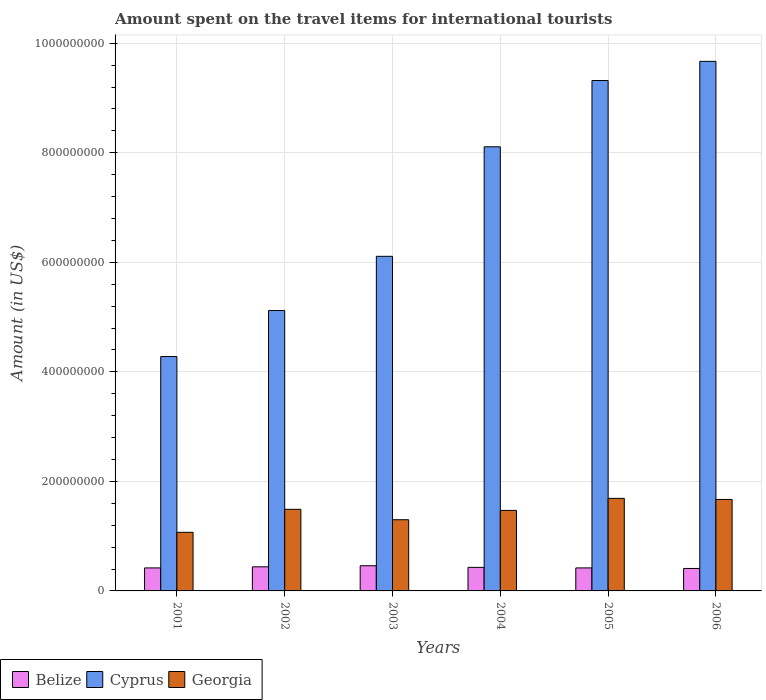How many groups of bars are there?
Provide a short and direct response. 6. Are the number of bars per tick equal to the number of legend labels?
Provide a short and direct response. Yes. How many bars are there on the 5th tick from the right?
Provide a short and direct response. 3. In how many cases, is the number of bars for a given year not equal to the number of legend labels?
Keep it short and to the point. 0. What is the amount spent on the travel items for international tourists in Cyprus in 2004?
Your response must be concise. 8.11e+08. Across all years, what is the maximum amount spent on the travel items for international tourists in Georgia?
Ensure brevity in your answer.  1.69e+08. Across all years, what is the minimum amount spent on the travel items for international tourists in Cyprus?
Provide a short and direct response. 4.28e+08. In which year was the amount spent on the travel items for international tourists in Georgia minimum?
Keep it short and to the point. 2001. What is the total amount spent on the travel items for international tourists in Georgia in the graph?
Ensure brevity in your answer.  8.69e+08. What is the difference between the amount spent on the travel items for international tourists in Georgia in 2001 and the amount spent on the travel items for international tourists in Cyprus in 2002?
Make the answer very short. -4.05e+08. What is the average amount spent on the travel items for international tourists in Belize per year?
Offer a very short reply. 4.30e+07. In the year 2003, what is the difference between the amount spent on the travel items for international tourists in Georgia and amount spent on the travel items for international tourists in Cyprus?
Your answer should be very brief. -4.81e+08. What is the ratio of the amount spent on the travel items for international tourists in Georgia in 2002 to that in 2003?
Give a very brief answer. 1.15. What is the difference between the highest and the second highest amount spent on the travel items for international tourists in Georgia?
Provide a short and direct response. 2.00e+06. What is the difference between the highest and the lowest amount spent on the travel items for international tourists in Belize?
Offer a terse response. 5.00e+06. In how many years, is the amount spent on the travel items for international tourists in Belize greater than the average amount spent on the travel items for international tourists in Belize taken over all years?
Your response must be concise. 2. Is the sum of the amount spent on the travel items for international tourists in Belize in 2001 and 2002 greater than the maximum amount spent on the travel items for international tourists in Cyprus across all years?
Ensure brevity in your answer.  No. What does the 3rd bar from the left in 2006 represents?
Provide a short and direct response. Georgia. What does the 1st bar from the right in 2006 represents?
Your response must be concise. Georgia. Is it the case that in every year, the sum of the amount spent on the travel items for international tourists in Georgia and amount spent on the travel items for international tourists in Cyprus is greater than the amount spent on the travel items for international tourists in Belize?
Provide a succinct answer. Yes. What is the difference between two consecutive major ticks on the Y-axis?
Ensure brevity in your answer.  2.00e+08. Does the graph contain any zero values?
Your answer should be very brief. No. Does the graph contain grids?
Ensure brevity in your answer.  Yes. How are the legend labels stacked?
Make the answer very short. Horizontal. What is the title of the graph?
Your answer should be very brief. Amount spent on the travel items for international tourists. What is the label or title of the Y-axis?
Your answer should be compact. Amount (in US$). What is the Amount (in US$) of Belize in 2001?
Give a very brief answer. 4.20e+07. What is the Amount (in US$) in Cyprus in 2001?
Your response must be concise. 4.28e+08. What is the Amount (in US$) of Georgia in 2001?
Your answer should be compact. 1.07e+08. What is the Amount (in US$) of Belize in 2002?
Ensure brevity in your answer.  4.40e+07. What is the Amount (in US$) in Cyprus in 2002?
Your answer should be compact. 5.12e+08. What is the Amount (in US$) of Georgia in 2002?
Your answer should be compact. 1.49e+08. What is the Amount (in US$) of Belize in 2003?
Provide a short and direct response. 4.60e+07. What is the Amount (in US$) in Cyprus in 2003?
Provide a succinct answer. 6.11e+08. What is the Amount (in US$) of Georgia in 2003?
Provide a short and direct response. 1.30e+08. What is the Amount (in US$) of Belize in 2004?
Provide a short and direct response. 4.30e+07. What is the Amount (in US$) in Cyprus in 2004?
Your response must be concise. 8.11e+08. What is the Amount (in US$) of Georgia in 2004?
Make the answer very short. 1.47e+08. What is the Amount (in US$) of Belize in 2005?
Keep it short and to the point. 4.20e+07. What is the Amount (in US$) in Cyprus in 2005?
Make the answer very short. 9.32e+08. What is the Amount (in US$) in Georgia in 2005?
Your response must be concise. 1.69e+08. What is the Amount (in US$) of Belize in 2006?
Provide a short and direct response. 4.10e+07. What is the Amount (in US$) of Cyprus in 2006?
Your answer should be compact. 9.67e+08. What is the Amount (in US$) in Georgia in 2006?
Your answer should be compact. 1.67e+08. Across all years, what is the maximum Amount (in US$) in Belize?
Provide a succinct answer. 4.60e+07. Across all years, what is the maximum Amount (in US$) in Cyprus?
Make the answer very short. 9.67e+08. Across all years, what is the maximum Amount (in US$) of Georgia?
Give a very brief answer. 1.69e+08. Across all years, what is the minimum Amount (in US$) of Belize?
Your answer should be very brief. 4.10e+07. Across all years, what is the minimum Amount (in US$) in Cyprus?
Make the answer very short. 4.28e+08. Across all years, what is the minimum Amount (in US$) in Georgia?
Offer a very short reply. 1.07e+08. What is the total Amount (in US$) of Belize in the graph?
Ensure brevity in your answer.  2.58e+08. What is the total Amount (in US$) in Cyprus in the graph?
Ensure brevity in your answer.  4.26e+09. What is the total Amount (in US$) of Georgia in the graph?
Ensure brevity in your answer.  8.69e+08. What is the difference between the Amount (in US$) in Belize in 2001 and that in 2002?
Offer a terse response. -2.00e+06. What is the difference between the Amount (in US$) of Cyprus in 2001 and that in 2002?
Provide a short and direct response. -8.40e+07. What is the difference between the Amount (in US$) in Georgia in 2001 and that in 2002?
Offer a terse response. -4.20e+07. What is the difference between the Amount (in US$) of Cyprus in 2001 and that in 2003?
Provide a short and direct response. -1.83e+08. What is the difference between the Amount (in US$) of Georgia in 2001 and that in 2003?
Give a very brief answer. -2.30e+07. What is the difference between the Amount (in US$) of Belize in 2001 and that in 2004?
Offer a very short reply. -1.00e+06. What is the difference between the Amount (in US$) in Cyprus in 2001 and that in 2004?
Offer a very short reply. -3.83e+08. What is the difference between the Amount (in US$) in Georgia in 2001 and that in 2004?
Provide a short and direct response. -4.00e+07. What is the difference between the Amount (in US$) in Belize in 2001 and that in 2005?
Offer a terse response. 0. What is the difference between the Amount (in US$) in Cyprus in 2001 and that in 2005?
Make the answer very short. -5.04e+08. What is the difference between the Amount (in US$) of Georgia in 2001 and that in 2005?
Offer a terse response. -6.20e+07. What is the difference between the Amount (in US$) of Belize in 2001 and that in 2006?
Provide a short and direct response. 1.00e+06. What is the difference between the Amount (in US$) of Cyprus in 2001 and that in 2006?
Offer a terse response. -5.39e+08. What is the difference between the Amount (in US$) in Georgia in 2001 and that in 2006?
Offer a very short reply. -6.00e+07. What is the difference between the Amount (in US$) in Belize in 2002 and that in 2003?
Offer a very short reply. -2.00e+06. What is the difference between the Amount (in US$) of Cyprus in 2002 and that in 2003?
Give a very brief answer. -9.90e+07. What is the difference between the Amount (in US$) of Georgia in 2002 and that in 2003?
Provide a succinct answer. 1.90e+07. What is the difference between the Amount (in US$) in Belize in 2002 and that in 2004?
Your response must be concise. 1.00e+06. What is the difference between the Amount (in US$) of Cyprus in 2002 and that in 2004?
Offer a very short reply. -2.99e+08. What is the difference between the Amount (in US$) in Cyprus in 2002 and that in 2005?
Provide a short and direct response. -4.20e+08. What is the difference between the Amount (in US$) in Georgia in 2002 and that in 2005?
Make the answer very short. -2.00e+07. What is the difference between the Amount (in US$) in Belize in 2002 and that in 2006?
Offer a very short reply. 3.00e+06. What is the difference between the Amount (in US$) in Cyprus in 2002 and that in 2006?
Keep it short and to the point. -4.55e+08. What is the difference between the Amount (in US$) in Georgia in 2002 and that in 2006?
Your response must be concise. -1.80e+07. What is the difference between the Amount (in US$) of Belize in 2003 and that in 2004?
Your response must be concise. 3.00e+06. What is the difference between the Amount (in US$) in Cyprus in 2003 and that in 2004?
Your answer should be compact. -2.00e+08. What is the difference between the Amount (in US$) of Georgia in 2003 and that in 2004?
Your answer should be very brief. -1.70e+07. What is the difference between the Amount (in US$) in Belize in 2003 and that in 2005?
Your answer should be compact. 4.00e+06. What is the difference between the Amount (in US$) of Cyprus in 2003 and that in 2005?
Make the answer very short. -3.21e+08. What is the difference between the Amount (in US$) in Georgia in 2003 and that in 2005?
Offer a terse response. -3.90e+07. What is the difference between the Amount (in US$) in Belize in 2003 and that in 2006?
Keep it short and to the point. 5.00e+06. What is the difference between the Amount (in US$) in Cyprus in 2003 and that in 2006?
Make the answer very short. -3.56e+08. What is the difference between the Amount (in US$) of Georgia in 2003 and that in 2006?
Your response must be concise. -3.70e+07. What is the difference between the Amount (in US$) of Cyprus in 2004 and that in 2005?
Make the answer very short. -1.21e+08. What is the difference between the Amount (in US$) in Georgia in 2004 and that in 2005?
Your answer should be compact. -2.20e+07. What is the difference between the Amount (in US$) of Belize in 2004 and that in 2006?
Give a very brief answer. 2.00e+06. What is the difference between the Amount (in US$) in Cyprus in 2004 and that in 2006?
Ensure brevity in your answer.  -1.56e+08. What is the difference between the Amount (in US$) of Georgia in 2004 and that in 2006?
Your answer should be very brief. -2.00e+07. What is the difference between the Amount (in US$) in Cyprus in 2005 and that in 2006?
Keep it short and to the point. -3.50e+07. What is the difference between the Amount (in US$) of Belize in 2001 and the Amount (in US$) of Cyprus in 2002?
Your answer should be very brief. -4.70e+08. What is the difference between the Amount (in US$) of Belize in 2001 and the Amount (in US$) of Georgia in 2002?
Offer a terse response. -1.07e+08. What is the difference between the Amount (in US$) in Cyprus in 2001 and the Amount (in US$) in Georgia in 2002?
Offer a very short reply. 2.79e+08. What is the difference between the Amount (in US$) of Belize in 2001 and the Amount (in US$) of Cyprus in 2003?
Your answer should be very brief. -5.69e+08. What is the difference between the Amount (in US$) of Belize in 2001 and the Amount (in US$) of Georgia in 2003?
Your answer should be very brief. -8.80e+07. What is the difference between the Amount (in US$) of Cyprus in 2001 and the Amount (in US$) of Georgia in 2003?
Offer a terse response. 2.98e+08. What is the difference between the Amount (in US$) in Belize in 2001 and the Amount (in US$) in Cyprus in 2004?
Provide a short and direct response. -7.69e+08. What is the difference between the Amount (in US$) in Belize in 2001 and the Amount (in US$) in Georgia in 2004?
Make the answer very short. -1.05e+08. What is the difference between the Amount (in US$) in Cyprus in 2001 and the Amount (in US$) in Georgia in 2004?
Keep it short and to the point. 2.81e+08. What is the difference between the Amount (in US$) of Belize in 2001 and the Amount (in US$) of Cyprus in 2005?
Your response must be concise. -8.90e+08. What is the difference between the Amount (in US$) in Belize in 2001 and the Amount (in US$) in Georgia in 2005?
Give a very brief answer. -1.27e+08. What is the difference between the Amount (in US$) of Cyprus in 2001 and the Amount (in US$) of Georgia in 2005?
Keep it short and to the point. 2.59e+08. What is the difference between the Amount (in US$) in Belize in 2001 and the Amount (in US$) in Cyprus in 2006?
Your answer should be compact. -9.25e+08. What is the difference between the Amount (in US$) in Belize in 2001 and the Amount (in US$) in Georgia in 2006?
Your answer should be compact. -1.25e+08. What is the difference between the Amount (in US$) of Cyprus in 2001 and the Amount (in US$) of Georgia in 2006?
Offer a very short reply. 2.61e+08. What is the difference between the Amount (in US$) in Belize in 2002 and the Amount (in US$) in Cyprus in 2003?
Ensure brevity in your answer.  -5.67e+08. What is the difference between the Amount (in US$) of Belize in 2002 and the Amount (in US$) of Georgia in 2003?
Your answer should be very brief. -8.60e+07. What is the difference between the Amount (in US$) of Cyprus in 2002 and the Amount (in US$) of Georgia in 2003?
Your answer should be compact. 3.82e+08. What is the difference between the Amount (in US$) of Belize in 2002 and the Amount (in US$) of Cyprus in 2004?
Offer a terse response. -7.67e+08. What is the difference between the Amount (in US$) of Belize in 2002 and the Amount (in US$) of Georgia in 2004?
Offer a very short reply. -1.03e+08. What is the difference between the Amount (in US$) of Cyprus in 2002 and the Amount (in US$) of Georgia in 2004?
Your answer should be very brief. 3.65e+08. What is the difference between the Amount (in US$) of Belize in 2002 and the Amount (in US$) of Cyprus in 2005?
Provide a short and direct response. -8.88e+08. What is the difference between the Amount (in US$) of Belize in 2002 and the Amount (in US$) of Georgia in 2005?
Provide a succinct answer. -1.25e+08. What is the difference between the Amount (in US$) of Cyprus in 2002 and the Amount (in US$) of Georgia in 2005?
Your answer should be very brief. 3.43e+08. What is the difference between the Amount (in US$) in Belize in 2002 and the Amount (in US$) in Cyprus in 2006?
Offer a terse response. -9.23e+08. What is the difference between the Amount (in US$) of Belize in 2002 and the Amount (in US$) of Georgia in 2006?
Ensure brevity in your answer.  -1.23e+08. What is the difference between the Amount (in US$) in Cyprus in 2002 and the Amount (in US$) in Georgia in 2006?
Ensure brevity in your answer.  3.45e+08. What is the difference between the Amount (in US$) of Belize in 2003 and the Amount (in US$) of Cyprus in 2004?
Your answer should be compact. -7.65e+08. What is the difference between the Amount (in US$) in Belize in 2003 and the Amount (in US$) in Georgia in 2004?
Your response must be concise. -1.01e+08. What is the difference between the Amount (in US$) in Cyprus in 2003 and the Amount (in US$) in Georgia in 2004?
Give a very brief answer. 4.64e+08. What is the difference between the Amount (in US$) in Belize in 2003 and the Amount (in US$) in Cyprus in 2005?
Your response must be concise. -8.86e+08. What is the difference between the Amount (in US$) of Belize in 2003 and the Amount (in US$) of Georgia in 2005?
Provide a succinct answer. -1.23e+08. What is the difference between the Amount (in US$) in Cyprus in 2003 and the Amount (in US$) in Georgia in 2005?
Your answer should be compact. 4.42e+08. What is the difference between the Amount (in US$) in Belize in 2003 and the Amount (in US$) in Cyprus in 2006?
Give a very brief answer. -9.21e+08. What is the difference between the Amount (in US$) of Belize in 2003 and the Amount (in US$) of Georgia in 2006?
Offer a very short reply. -1.21e+08. What is the difference between the Amount (in US$) in Cyprus in 2003 and the Amount (in US$) in Georgia in 2006?
Keep it short and to the point. 4.44e+08. What is the difference between the Amount (in US$) in Belize in 2004 and the Amount (in US$) in Cyprus in 2005?
Make the answer very short. -8.89e+08. What is the difference between the Amount (in US$) in Belize in 2004 and the Amount (in US$) in Georgia in 2005?
Offer a terse response. -1.26e+08. What is the difference between the Amount (in US$) of Cyprus in 2004 and the Amount (in US$) of Georgia in 2005?
Your answer should be very brief. 6.42e+08. What is the difference between the Amount (in US$) in Belize in 2004 and the Amount (in US$) in Cyprus in 2006?
Provide a succinct answer. -9.24e+08. What is the difference between the Amount (in US$) of Belize in 2004 and the Amount (in US$) of Georgia in 2006?
Your answer should be compact. -1.24e+08. What is the difference between the Amount (in US$) in Cyprus in 2004 and the Amount (in US$) in Georgia in 2006?
Provide a short and direct response. 6.44e+08. What is the difference between the Amount (in US$) in Belize in 2005 and the Amount (in US$) in Cyprus in 2006?
Give a very brief answer. -9.25e+08. What is the difference between the Amount (in US$) in Belize in 2005 and the Amount (in US$) in Georgia in 2006?
Offer a very short reply. -1.25e+08. What is the difference between the Amount (in US$) in Cyprus in 2005 and the Amount (in US$) in Georgia in 2006?
Your answer should be compact. 7.65e+08. What is the average Amount (in US$) of Belize per year?
Keep it short and to the point. 4.30e+07. What is the average Amount (in US$) of Cyprus per year?
Keep it short and to the point. 7.10e+08. What is the average Amount (in US$) of Georgia per year?
Your response must be concise. 1.45e+08. In the year 2001, what is the difference between the Amount (in US$) of Belize and Amount (in US$) of Cyprus?
Offer a very short reply. -3.86e+08. In the year 2001, what is the difference between the Amount (in US$) in Belize and Amount (in US$) in Georgia?
Provide a succinct answer. -6.50e+07. In the year 2001, what is the difference between the Amount (in US$) in Cyprus and Amount (in US$) in Georgia?
Keep it short and to the point. 3.21e+08. In the year 2002, what is the difference between the Amount (in US$) in Belize and Amount (in US$) in Cyprus?
Provide a succinct answer. -4.68e+08. In the year 2002, what is the difference between the Amount (in US$) of Belize and Amount (in US$) of Georgia?
Your answer should be very brief. -1.05e+08. In the year 2002, what is the difference between the Amount (in US$) of Cyprus and Amount (in US$) of Georgia?
Keep it short and to the point. 3.63e+08. In the year 2003, what is the difference between the Amount (in US$) of Belize and Amount (in US$) of Cyprus?
Give a very brief answer. -5.65e+08. In the year 2003, what is the difference between the Amount (in US$) in Belize and Amount (in US$) in Georgia?
Your answer should be very brief. -8.40e+07. In the year 2003, what is the difference between the Amount (in US$) of Cyprus and Amount (in US$) of Georgia?
Your response must be concise. 4.81e+08. In the year 2004, what is the difference between the Amount (in US$) in Belize and Amount (in US$) in Cyprus?
Provide a succinct answer. -7.68e+08. In the year 2004, what is the difference between the Amount (in US$) of Belize and Amount (in US$) of Georgia?
Your response must be concise. -1.04e+08. In the year 2004, what is the difference between the Amount (in US$) in Cyprus and Amount (in US$) in Georgia?
Give a very brief answer. 6.64e+08. In the year 2005, what is the difference between the Amount (in US$) in Belize and Amount (in US$) in Cyprus?
Give a very brief answer. -8.90e+08. In the year 2005, what is the difference between the Amount (in US$) of Belize and Amount (in US$) of Georgia?
Make the answer very short. -1.27e+08. In the year 2005, what is the difference between the Amount (in US$) of Cyprus and Amount (in US$) of Georgia?
Provide a short and direct response. 7.63e+08. In the year 2006, what is the difference between the Amount (in US$) of Belize and Amount (in US$) of Cyprus?
Give a very brief answer. -9.26e+08. In the year 2006, what is the difference between the Amount (in US$) in Belize and Amount (in US$) in Georgia?
Your answer should be very brief. -1.26e+08. In the year 2006, what is the difference between the Amount (in US$) in Cyprus and Amount (in US$) in Georgia?
Your answer should be compact. 8.00e+08. What is the ratio of the Amount (in US$) in Belize in 2001 to that in 2002?
Offer a very short reply. 0.95. What is the ratio of the Amount (in US$) of Cyprus in 2001 to that in 2002?
Provide a succinct answer. 0.84. What is the ratio of the Amount (in US$) of Georgia in 2001 to that in 2002?
Provide a succinct answer. 0.72. What is the ratio of the Amount (in US$) of Cyprus in 2001 to that in 2003?
Keep it short and to the point. 0.7. What is the ratio of the Amount (in US$) of Georgia in 2001 to that in 2003?
Offer a terse response. 0.82. What is the ratio of the Amount (in US$) of Belize in 2001 to that in 2004?
Your response must be concise. 0.98. What is the ratio of the Amount (in US$) in Cyprus in 2001 to that in 2004?
Make the answer very short. 0.53. What is the ratio of the Amount (in US$) in Georgia in 2001 to that in 2004?
Offer a terse response. 0.73. What is the ratio of the Amount (in US$) of Cyprus in 2001 to that in 2005?
Ensure brevity in your answer.  0.46. What is the ratio of the Amount (in US$) in Georgia in 2001 to that in 2005?
Provide a succinct answer. 0.63. What is the ratio of the Amount (in US$) in Belize in 2001 to that in 2006?
Ensure brevity in your answer.  1.02. What is the ratio of the Amount (in US$) in Cyprus in 2001 to that in 2006?
Offer a terse response. 0.44. What is the ratio of the Amount (in US$) in Georgia in 2001 to that in 2006?
Give a very brief answer. 0.64. What is the ratio of the Amount (in US$) in Belize in 2002 to that in 2003?
Provide a short and direct response. 0.96. What is the ratio of the Amount (in US$) in Cyprus in 2002 to that in 2003?
Provide a short and direct response. 0.84. What is the ratio of the Amount (in US$) of Georgia in 2002 to that in 2003?
Provide a short and direct response. 1.15. What is the ratio of the Amount (in US$) in Belize in 2002 to that in 2004?
Your answer should be very brief. 1.02. What is the ratio of the Amount (in US$) in Cyprus in 2002 to that in 2004?
Provide a short and direct response. 0.63. What is the ratio of the Amount (in US$) of Georgia in 2002 to that in 2004?
Ensure brevity in your answer.  1.01. What is the ratio of the Amount (in US$) in Belize in 2002 to that in 2005?
Provide a succinct answer. 1.05. What is the ratio of the Amount (in US$) in Cyprus in 2002 to that in 2005?
Offer a terse response. 0.55. What is the ratio of the Amount (in US$) of Georgia in 2002 to that in 2005?
Offer a very short reply. 0.88. What is the ratio of the Amount (in US$) in Belize in 2002 to that in 2006?
Keep it short and to the point. 1.07. What is the ratio of the Amount (in US$) of Cyprus in 2002 to that in 2006?
Make the answer very short. 0.53. What is the ratio of the Amount (in US$) of Georgia in 2002 to that in 2006?
Your response must be concise. 0.89. What is the ratio of the Amount (in US$) of Belize in 2003 to that in 2004?
Give a very brief answer. 1.07. What is the ratio of the Amount (in US$) in Cyprus in 2003 to that in 2004?
Offer a very short reply. 0.75. What is the ratio of the Amount (in US$) of Georgia in 2003 to that in 2004?
Ensure brevity in your answer.  0.88. What is the ratio of the Amount (in US$) in Belize in 2003 to that in 2005?
Offer a very short reply. 1.1. What is the ratio of the Amount (in US$) in Cyprus in 2003 to that in 2005?
Keep it short and to the point. 0.66. What is the ratio of the Amount (in US$) of Georgia in 2003 to that in 2005?
Offer a terse response. 0.77. What is the ratio of the Amount (in US$) in Belize in 2003 to that in 2006?
Your response must be concise. 1.12. What is the ratio of the Amount (in US$) in Cyprus in 2003 to that in 2006?
Your response must be concise. 0.63. What is the ratio of the Amount (in US$) in Georgia in 2003 to that in 2006?
Make the answer very short. 0.78. What is the ratio of the Amount (in US$) in Belize in 2004 to that in 2005?
Give a very brief answer. 1.02. What is the ratio of the Amount (in US$) of Cyprus in 2004 to that in 2005?
Provide a short and direct response. 0.87. What is the ratio of the Amount (in US$) of Georgia in 2004 to that in 2005?
Provide a succinct answer. 0.87. What is the ratio of the Amount (in US$) of Belize in 2004 to that in 2006?
Ensure brevity in your answer.  1.05. What is the ratio of the Amount (in US$) of Cyprus in 2004 to that in 2006?
Make the answer very short. 0.84. What is the ratio of the Amount (in US$) in Georgia in 2004 to that in 2006?
Your response must be concise. 0.88. What is the ratio of the Amount (in US$) in Belize in 2005 to that in 2006?
Provide a succinct answer. 1.02. What is the ratio of the Amount (in US$) of Cyprus in 2005 to that in 2006?
Provide a short and direct response. 0.96. What is the difference between the highest and the second highest Amount (in US$) in Belize?
Your answer should be compact. 2.00e+06. What is the difference between the highest and the second highest Amount (in US$) in Cyprus?
Ensure brevity in your answer.  3.50e+07. What is the difference between the highest and the second highest Amount (in US$) of Georgia?
Offer a terse response. 2.00e+06. What is the difference between the highest and the lowest Amount (in US$) of Belize?
Keep it short and to the point. 5.00e+06. What is the difference between the highest and the lowest Amount (in US$) of Cyprus?
Give a very brief answer. 5.39e+08. What is the difference between the highest and the lowest Amount (in US$) of Georgia?
Make the answer very short. 6.20e+07. 